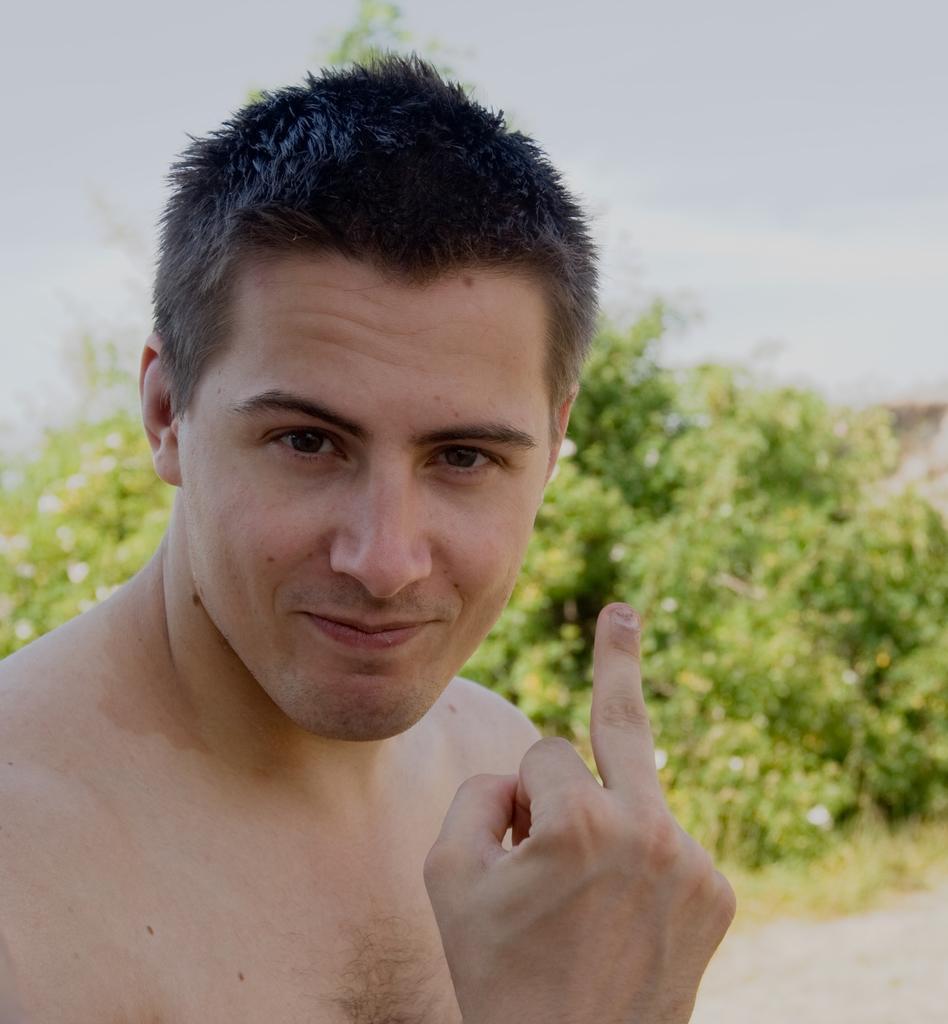Can you describe this image briefly? In the image there is a man and behind the man there are some trees. 